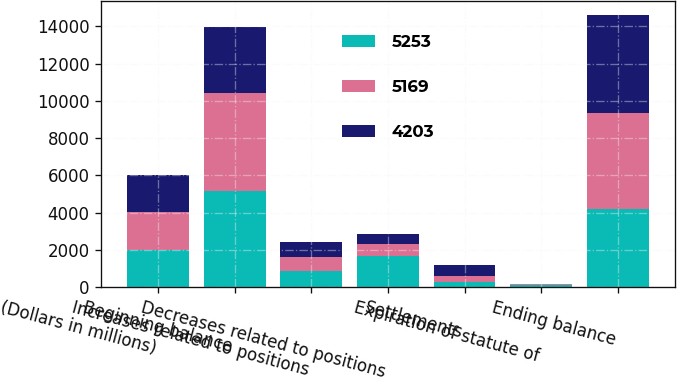Convert chart. <chart><loc_0><loc_0><loc_500><loc_500><stacked_bar_chart><ecel><fcel>(Dollars in millions)<fcel>Beginning balance<fcel>Increases related to positions<fcel>Decreases related to positions<fcel>Settlements<fcel>Expiration of statute of<fcel>Ending balance<nl><fcel>5253<fcel>2011<fcel>5169<fcel>879<fcel>1669<fcel>277<fcel>118<fcel>4203<nl><fcel>5169<fcel>2010<fcel>5253<fcel>755<fcel>657<fcel>305<fcel>49<fcel>5169<nl><fcel>4203<fcel>2009<fcel>3541<fcel>791<fcel>554<fcel>615<fcel>15<fcel>5253<nl></chart> 